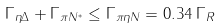Convert formula to latex. <formula><loc_0><loc_0><loc_500><loc_500>\Gamma _ { \eta \Delta } + \Gamma _ { \pi N ^ { * } } \leq \Gamma _ { \pi \eta N } = 0 . 3 4 \, \Gamma _ { R }</formula> 